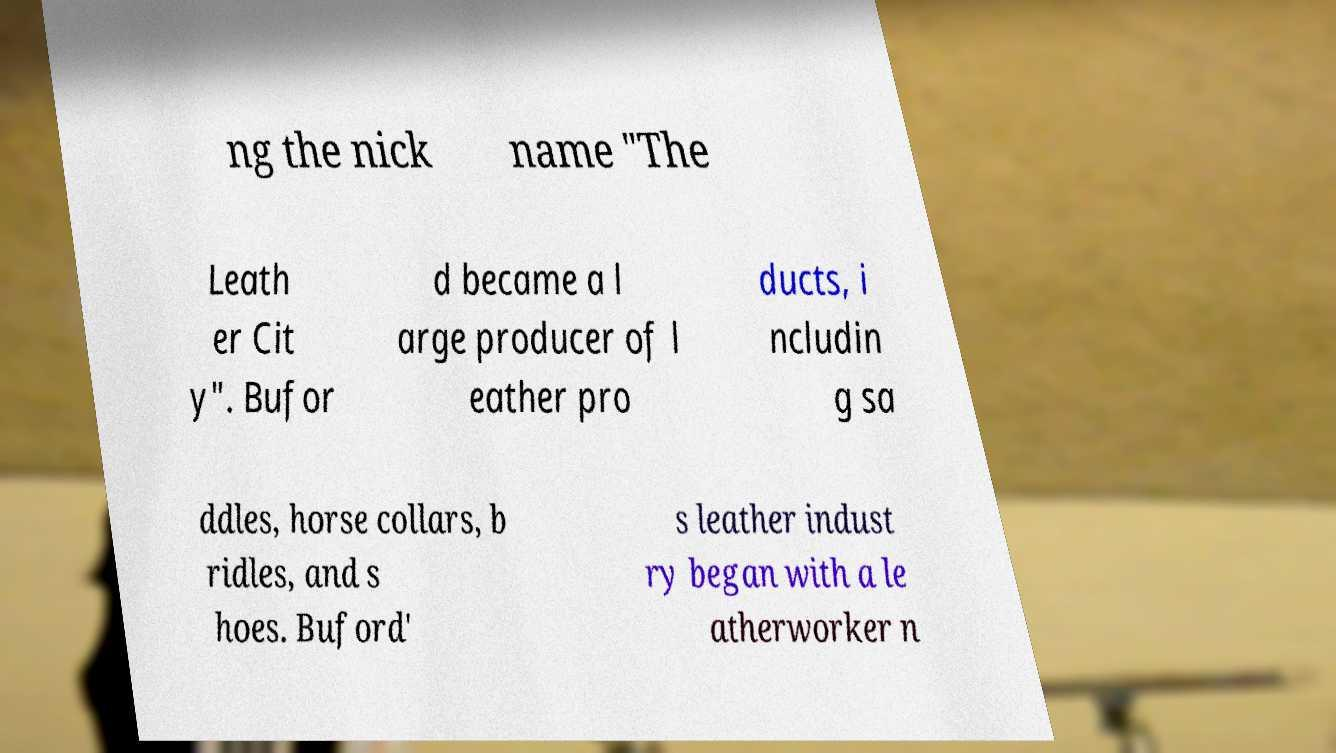Could you extract and type out the text from this image? ng the nick name "The Leath er Cit y". Bufor d became a l arge producer of l eather pro ducts, i ncludin g sa ddles, horse collars, b ridles, and s hoes. Buford' s leather indust ry began with a le atherworker n 